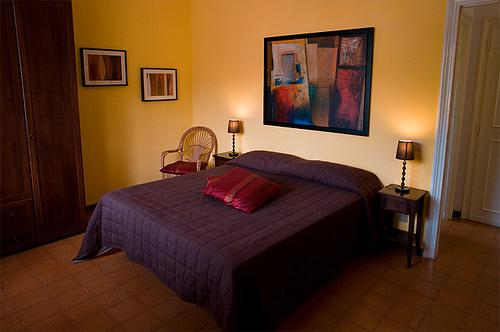Question: what room is shown?
Choices:
A. Kitchen.
B. Bedroom.
C. Dining room.
D. Living room.
Answer with the letter. Answer: B Question: when was the photo taken?
Choices:
A. Day.
B. Evening.
C. Night.
D. Dusk.
Answer with the letter. Answer: C Question: why is there a photo above bed?
Choices:
A. Memories.
B. Decoration.
C. To show creativity.
D. To make use of a picture frame.
Answer with the letter. Answer: B Question: what color are the walls?
Choices:
A. White.
B. Red.
C. Yellow.
D. Pink.
Answer with the letter. Answer: C Question: how many lamps are there?
Choices:
A. 3.
B. 4.
C. 5.
D. 2.
Answer with the letter. Answer: D 